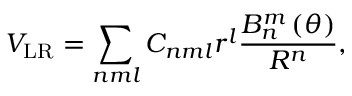<formula> <loc_0><loc_0><loc_500><loc_500>V _ { L R } = \sum _ { n m l } C _ { n m l } r ^ { l } \frac { B _ { n } ^ { m } \left ( \theta \right ) } { R ^ { n } } ,</formula> 